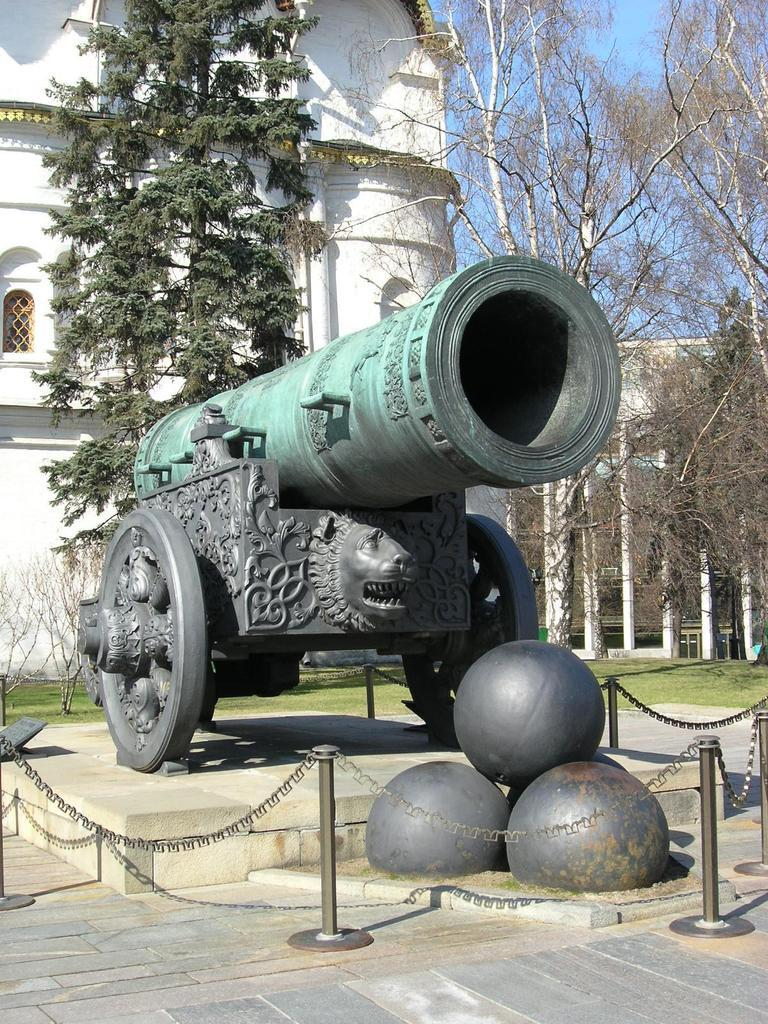What is the main subject of the image? The main subject of the image is a tsar cannon. What can be seen in the background of the image? There is a building and trees in the background of the image. What type of distribution system is visible in the image? There is no distribution system present in the image; it features a tsar cannon and a background with a building and trees. Can you tell me how many seashores are visible in the image? There are no seashores visible in the image; it features a tsar cannon and a background with a building and trees. 